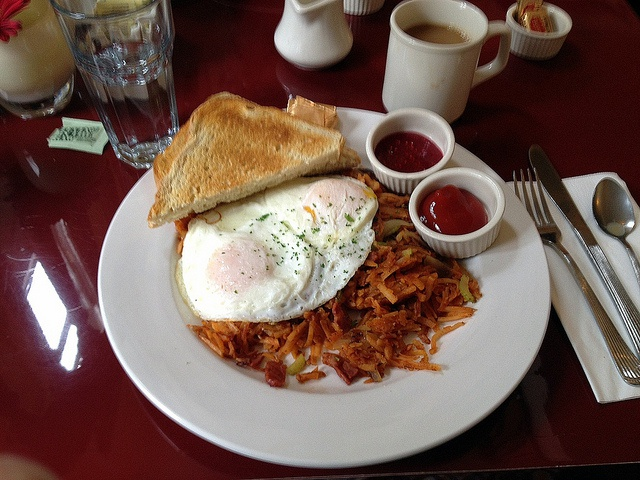Describe the objects in this image and their specific colors. I can see dining table in maroon, black, white, and gray tones, dining table in maroon, black, gray, and darkgray tones, sandwich in maroon, olive, and tan tones, cup in maroon, gray, and black tones, and cup in maroon, darkgray, and gray tones in this image. 